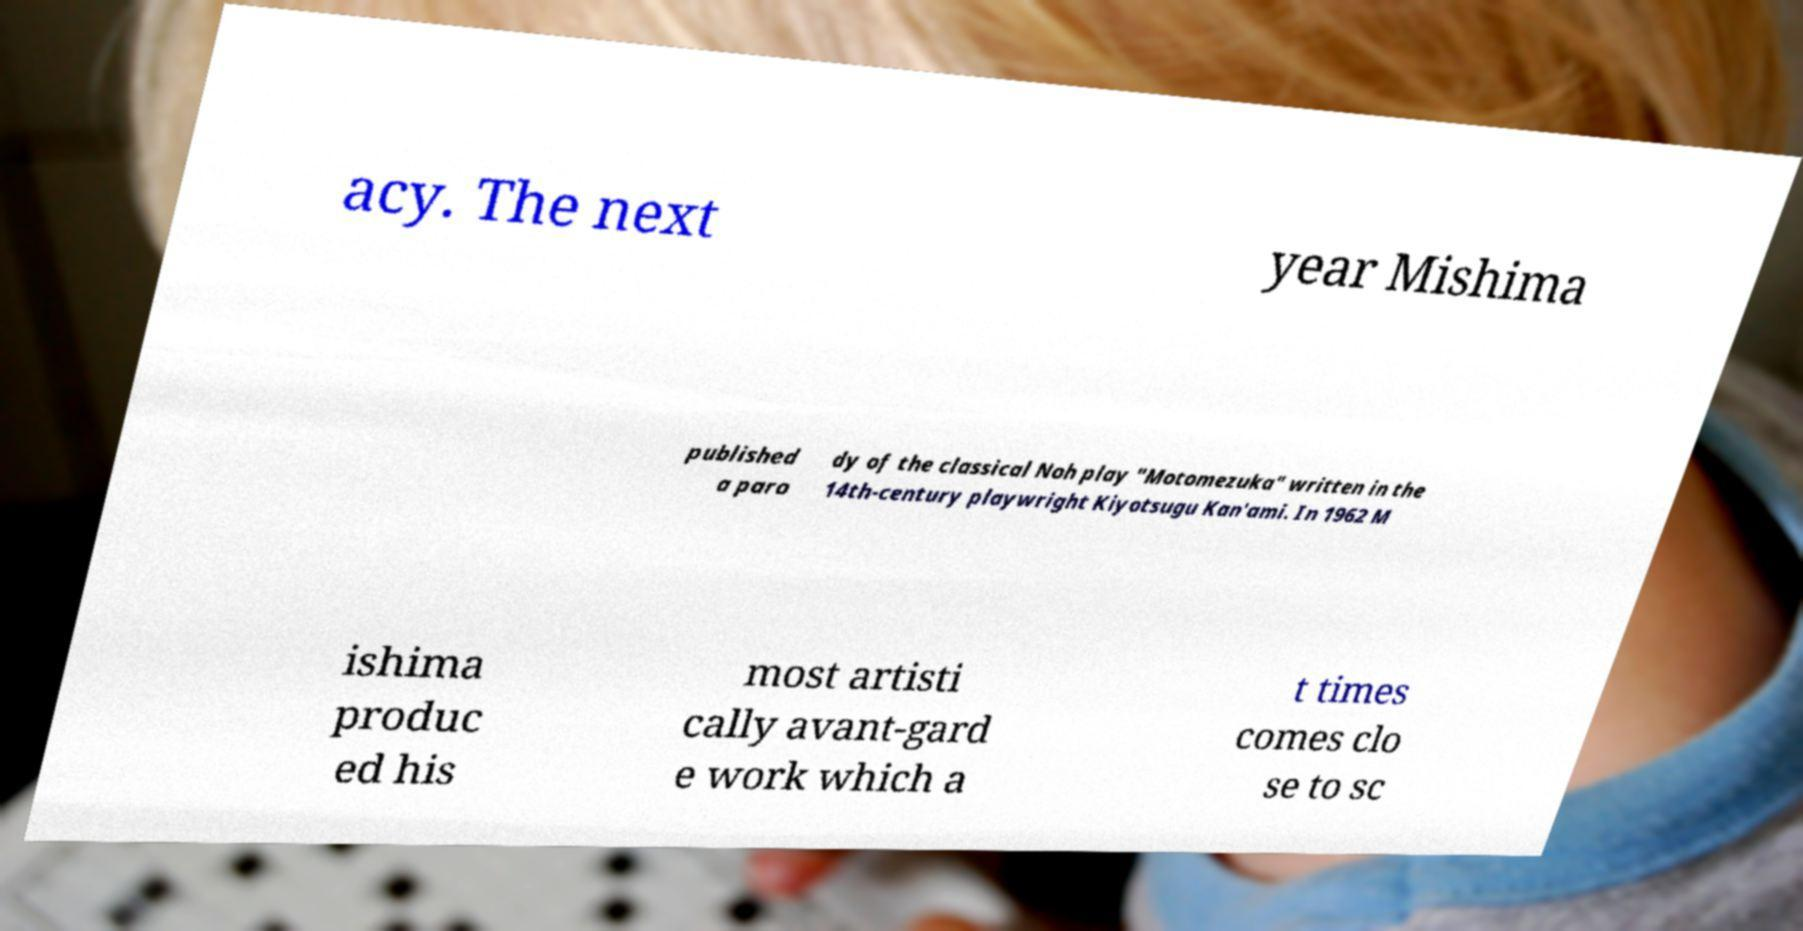Can you accurately transcribe the text from the provided image for me? acy. The next year Mishima published a paro dy of the classical Noh play "Motomezuka" written in the 14th-century playwright Kiyotsugu Kan'ami. In 1962 M ishima produc ed his most artisti cally avant-gard e work which a t times comes clo se to sc 